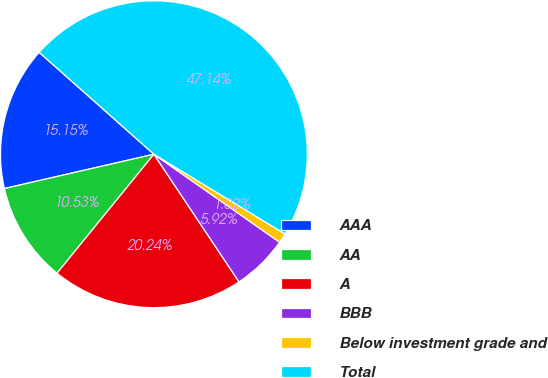Convert chart. <chart><loc_0><loc_0><loc_500><loc_500><pie_chart><fcel>AAA<fcel>AA<fcel>A<fcel>BBB<fcel>Below investment grade and<fcel>Total<nl><fcel>15.15%<fcel>10.53%<fcel>20.24%<fcel>5.92%<fcel>1.02%<fcel>47.14%<nl></chart> 